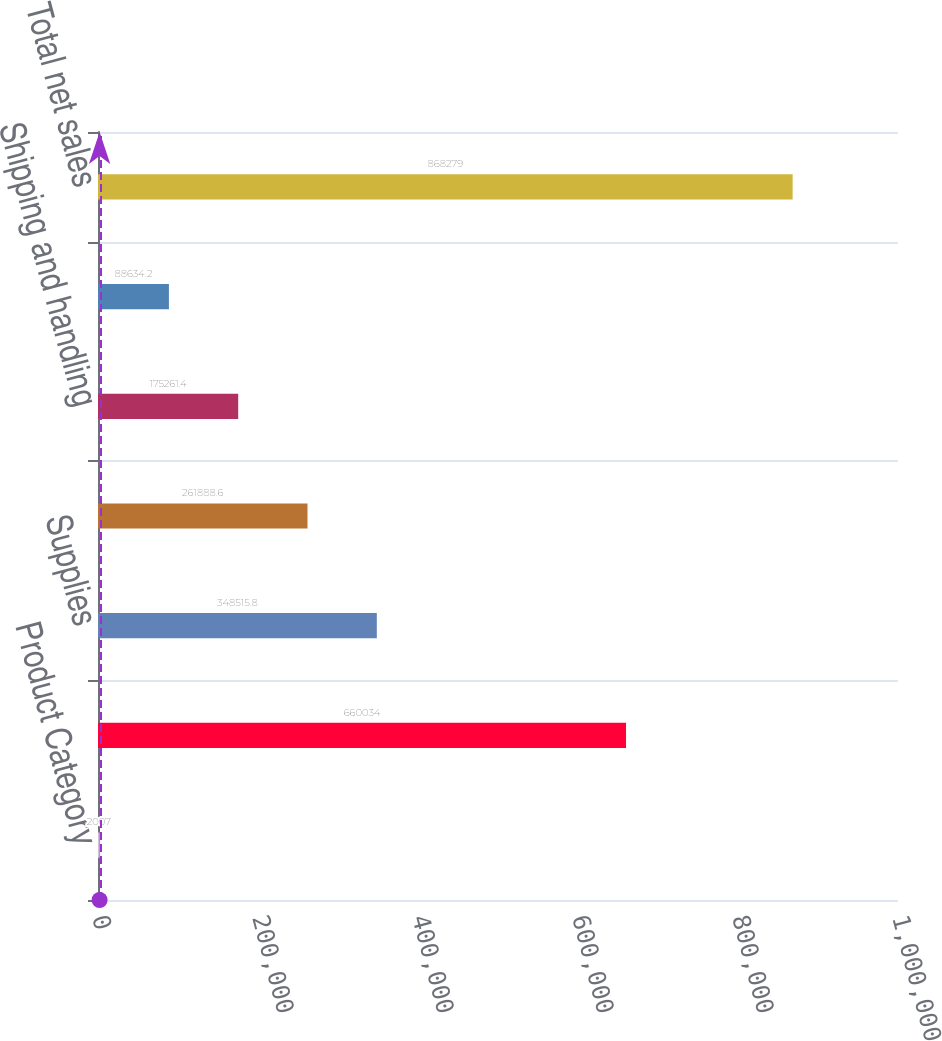Convert chart. <chart><loc_0><loc_0><loc_500><loc_500><bar_chart><fcel>Product Category<fcel>Hardware<fcel>Supplies<fcel>Service and software<fcel>Shipping and handling<fcel>Cash flow hedging activities<fcel>Total net sales<nl><fcel>2007<fcel>660034<fcel>348516<fcel>261889<fcel>175261<fcel>88634.2<fcel>868279<nl></chart> 